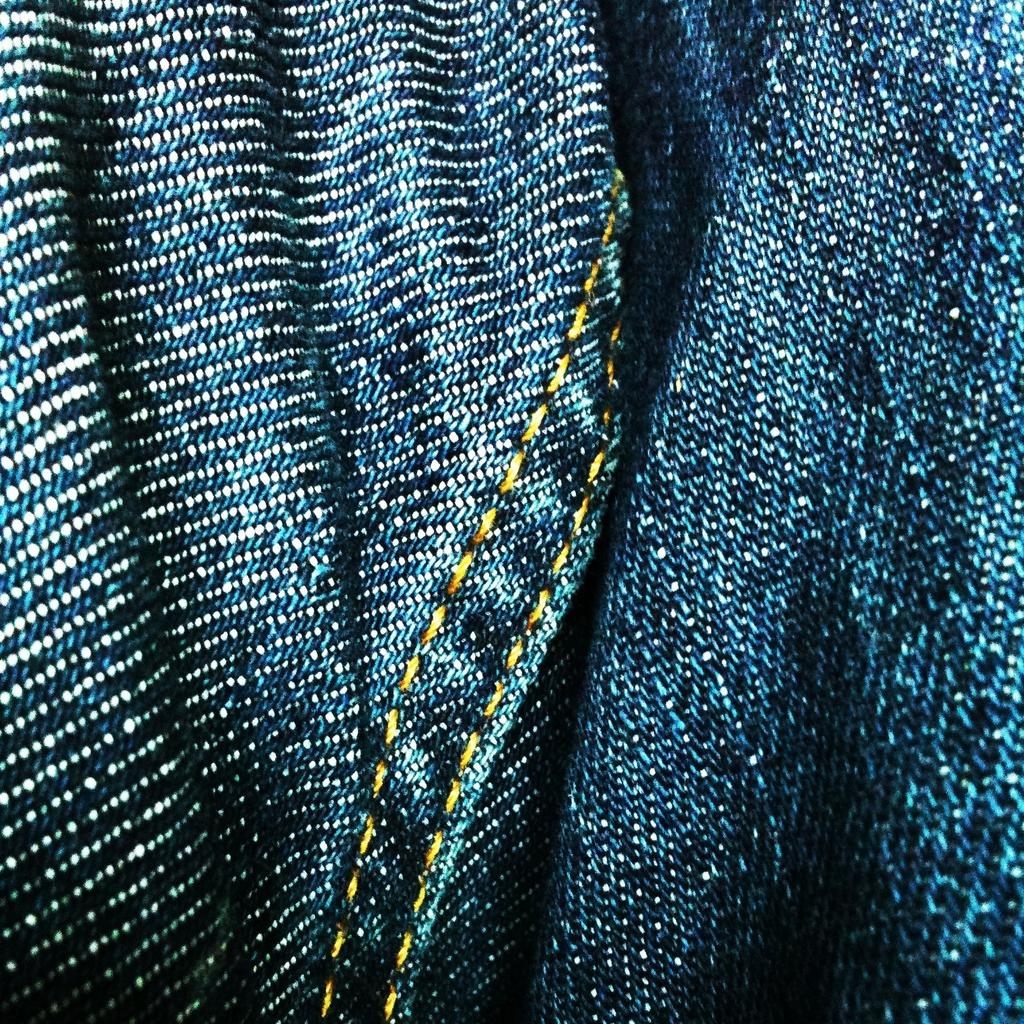What type of clothing is visible in the image? There is a blue color jeans cloth in the image. How many arms are visible on the cactus in the image? There is no cactus present in the image, so it is not possible to determine the number of arms. 